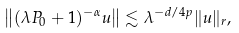Convert formula to latex. <formula><loc_0><loc_0><loc_500><loc_500>\left \| ( \lambda P _ { 0 } + 1 ) ^ { - \alpha } u \right \| \lesssim \lambda ^ { - d / 4 p } \| u \| _ { r } ,</formula> 